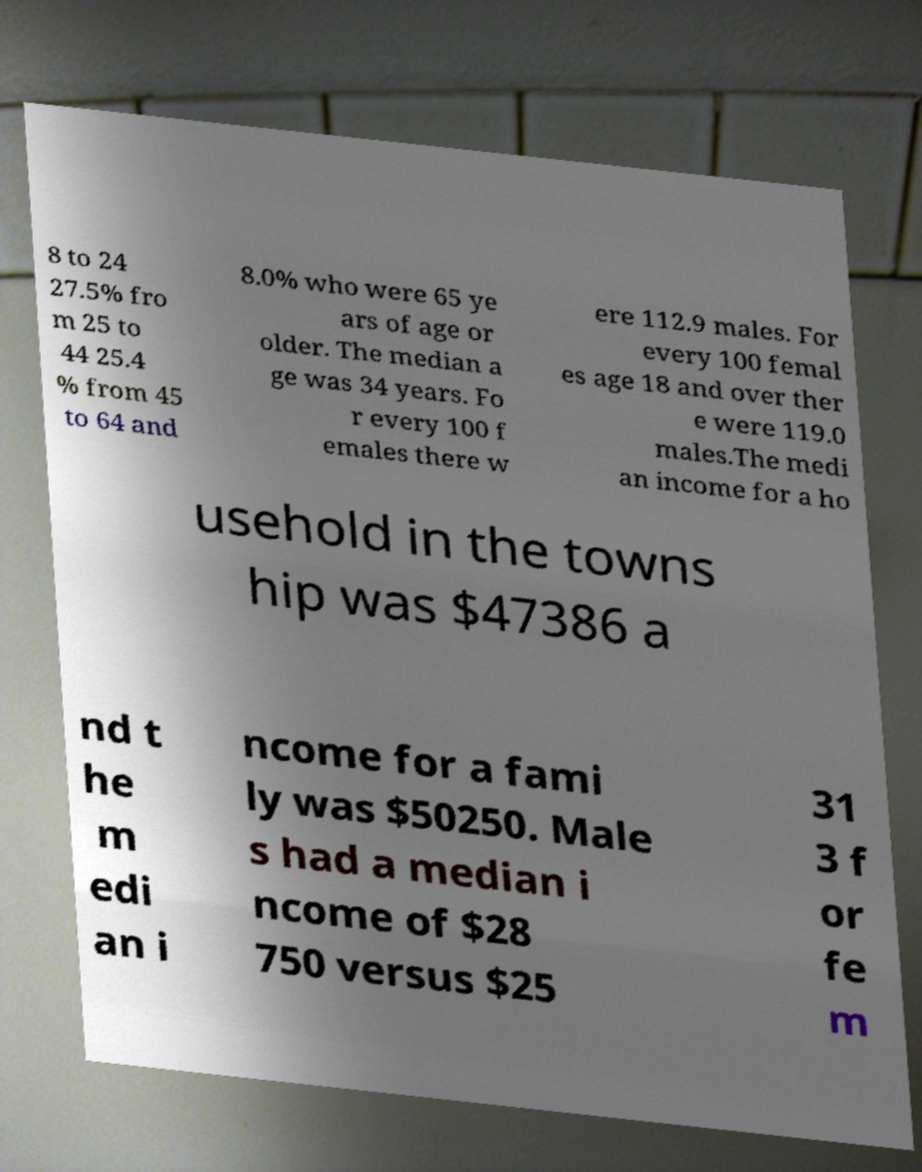What messages or text are displayed in this image? I need them in a readable, typed format. 8 to 24 27.5% fro m 25 to 44 25.4 % from 45 to 64 and 8.0% who were 65 ye ars of age or older. The median a ge was 34 years. Fo r every 100 f emales there w ere 112.9 males. For every 100 femal es age 18 and over ther e were 119.0 males.The medi an income for a ho usehold in the towns hip was $47386 a nd t he m edi an i ncome for a fami ly was $50250. Male s had a median i ncome of $28 750 versus $25 31 3 f or fe m 